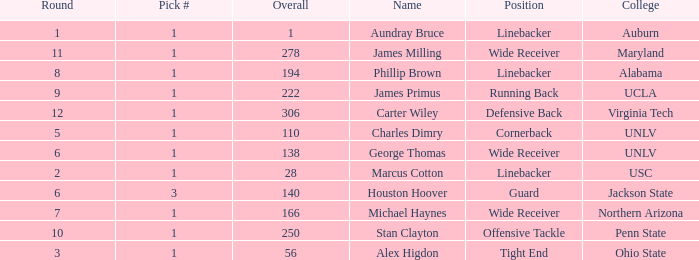In what Round was George Thomas Picked? 6.0. 